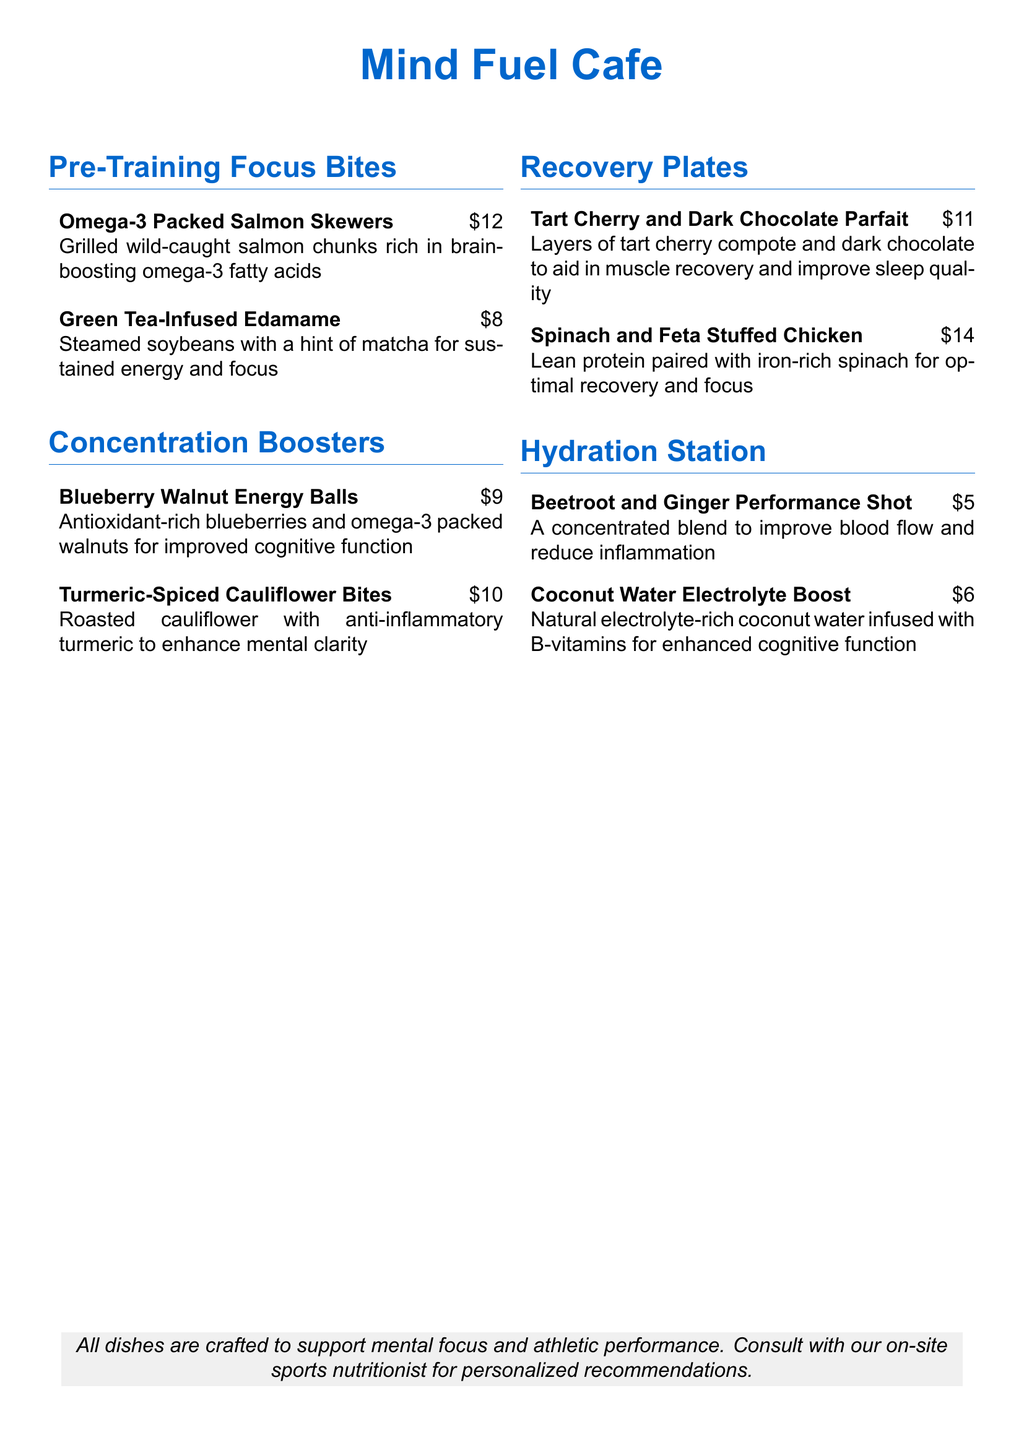What are the names of the Concentration Boosters? The Concentration Boosters section lists two items: Blueberry Walnut Energy Balls and Turmeric-Spiced Cauliflower Bites.
Answer: Blueberry Walnut Energy Balls, Turmeric-Spiced Cauliflower Bites How much do the Omega-3 Packed Salmon Skewers cost? The cost of the Omega-3 Packed Salmon Skewers is provided next to the dish name.
Answer: $12 Which dish is rich in brain-boosting omega-3 fatty acids? The Omega-3 Packed Salmon Skewers are described as rich in brain-boosting omega-3 fatty acids.
Answer: Omega-3 Packed Salmon Skewers How many items are in the Recovery Plates section? The Recovery Plates section lists two dishes, indicating the total number of items.
Answer: 2 What is the price of the Beetroot and Ginger Performance Shot? The price of the Beetroot and Ginger Performance Shot is listed next to the item name.
Answer: $5 What type of milk is used in the Hydration Station section? The Hydration Station lists drinks, but there is no milk mentioned; only beverages are highlighted.
Answer: None How many total sections are in the menu? The menu has four distinct sections: Pre-Training Focus Bites, Concentration Boosters, Recovery Plates, and Hydration Station.
Answer: 4 Which item is paired with iron-rich spinach for optimal recovery? The Spinach and Feta Stuffed Chicken is mentioned as being paired with iron-rich spinach for optimal recovery.
Answer: Spinach and Feta Stuffed Chicken 